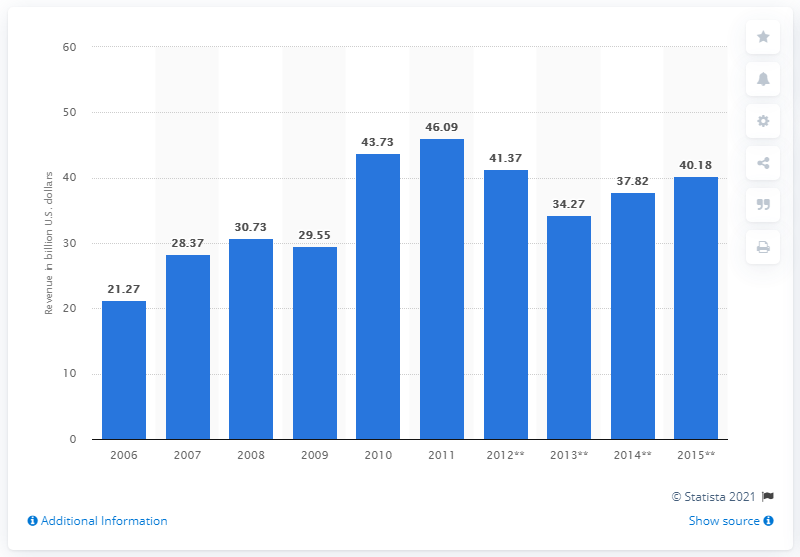Outline some significant characteristics in this image. In 2015, the market for mechanical engineering in India was valued at approximately 34.27. In 2015, the market for mechanical engineering in India was approximately 40.18 dollars. 